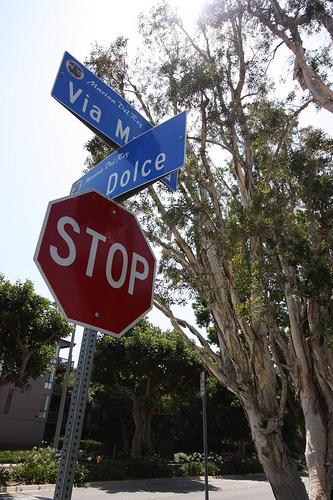What is written on the red and white sign?
Quick response, please. Stop. Which language is on the sign?
Concise answer only. English. Would you take your dog for a walk along this street?
Answer briefly. Yes. 